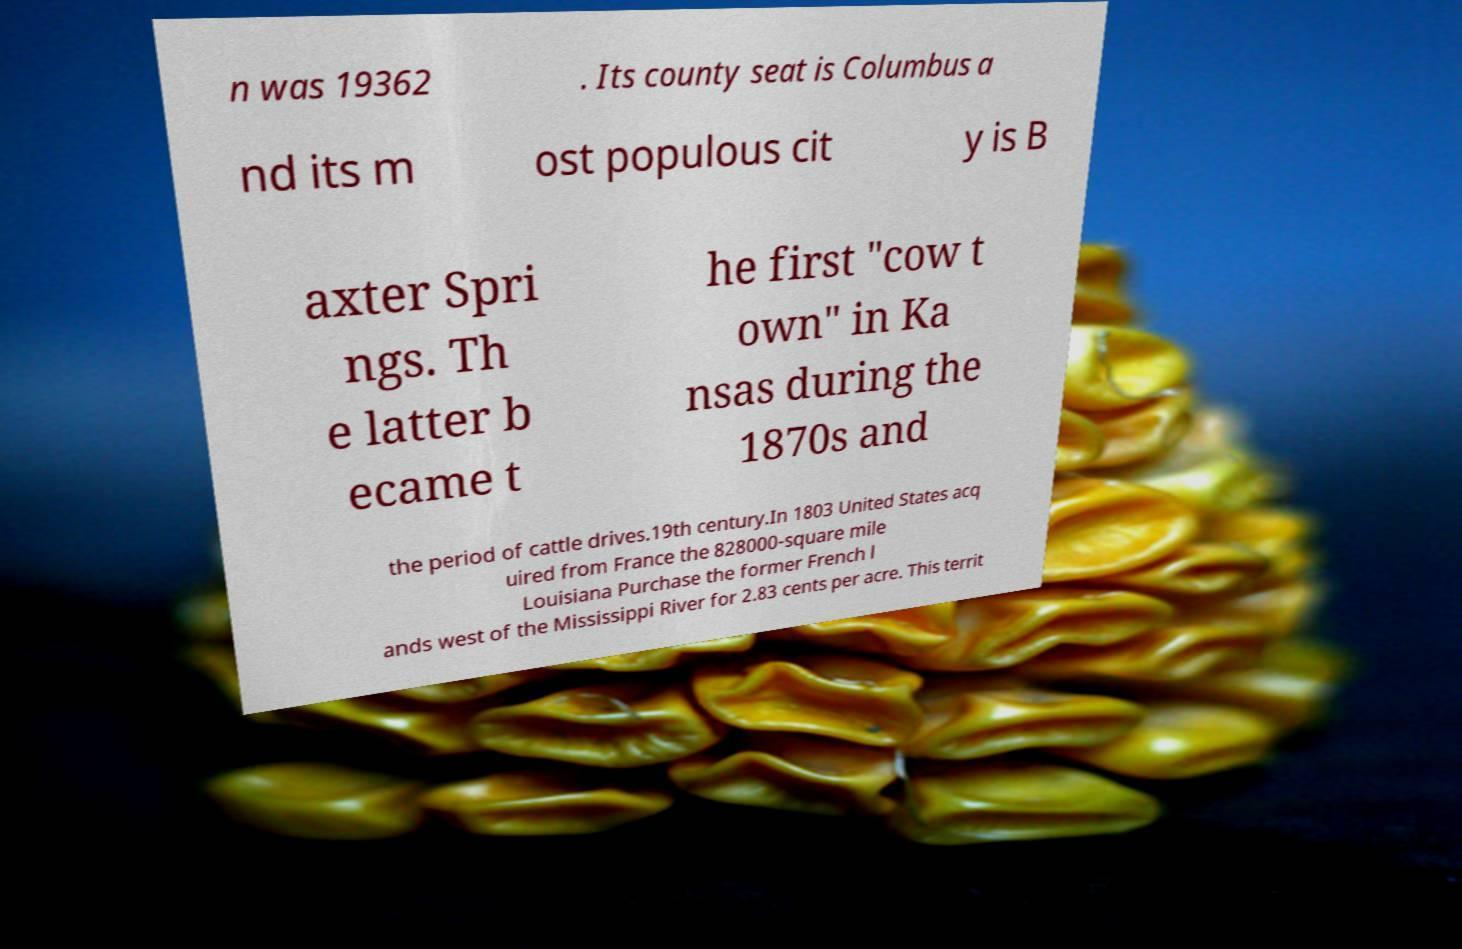Please read and relay the text visible in this image. What does it say? n was 19362 . Its county seat is Columbus a nd its m ost populous cit y is B axter Spri ngs. Th e latter b ecame t he first "cow t own" in Ka nsas during the 1870s and the period of cattle drives.19th century.In 1803 United States acq uired from France the 828000-square mile Louisiana Purchase the former French l ands west of the Mississippi River for 2.83 cents per acre. This territ 